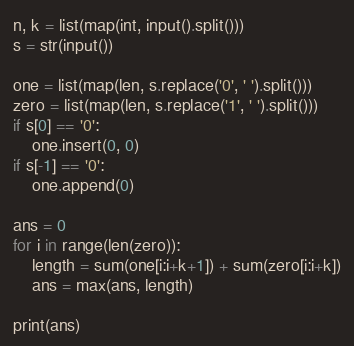<code> <loc_0><loc_0><loc_500><loc_500><_Python_>n, k = list(map(int, input().split()))
s = str(input())

one = list(map(len, s.replace('0', ' ').split()))
zero = list(map(len, s.replace('1', ' ').split()))
if s[0] == '0':
    one.insert(0, 0)
if s[-1] == '0':
    one.append(0)
    
ans = 0
for i in range(len(zero)):
    length = sum(one[i:i+k+1]) + sum(zero[i:i+k])
    ans = max(ans, length)
    
print(ans)</code> 